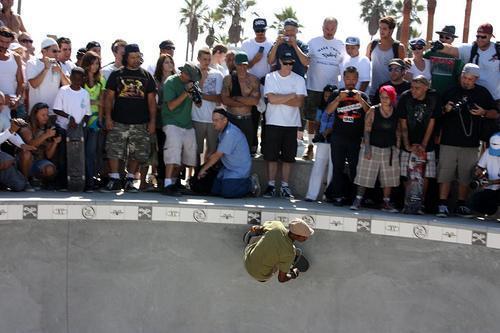What style of skateboarding is this?
From the following four choices, select the correct answer to address the question.
Options: Street, park, freestyle, vert. Vert. 